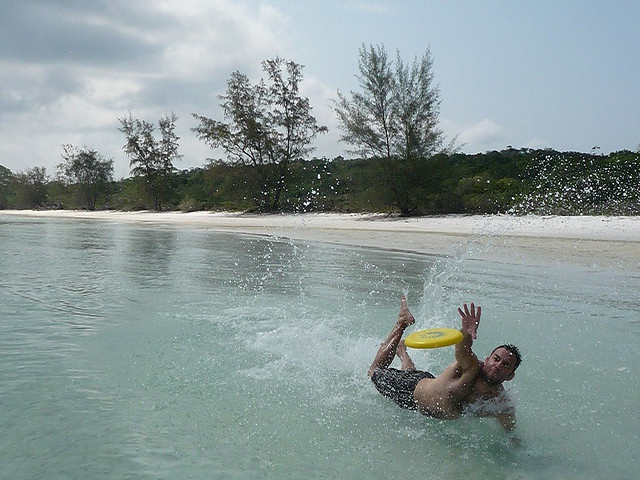Describe the objects in this image and their specific colors. I can see people in darkgray, black, and gray tones and frisbee in darkgray, tan, khaki, and olive tones in this image. 